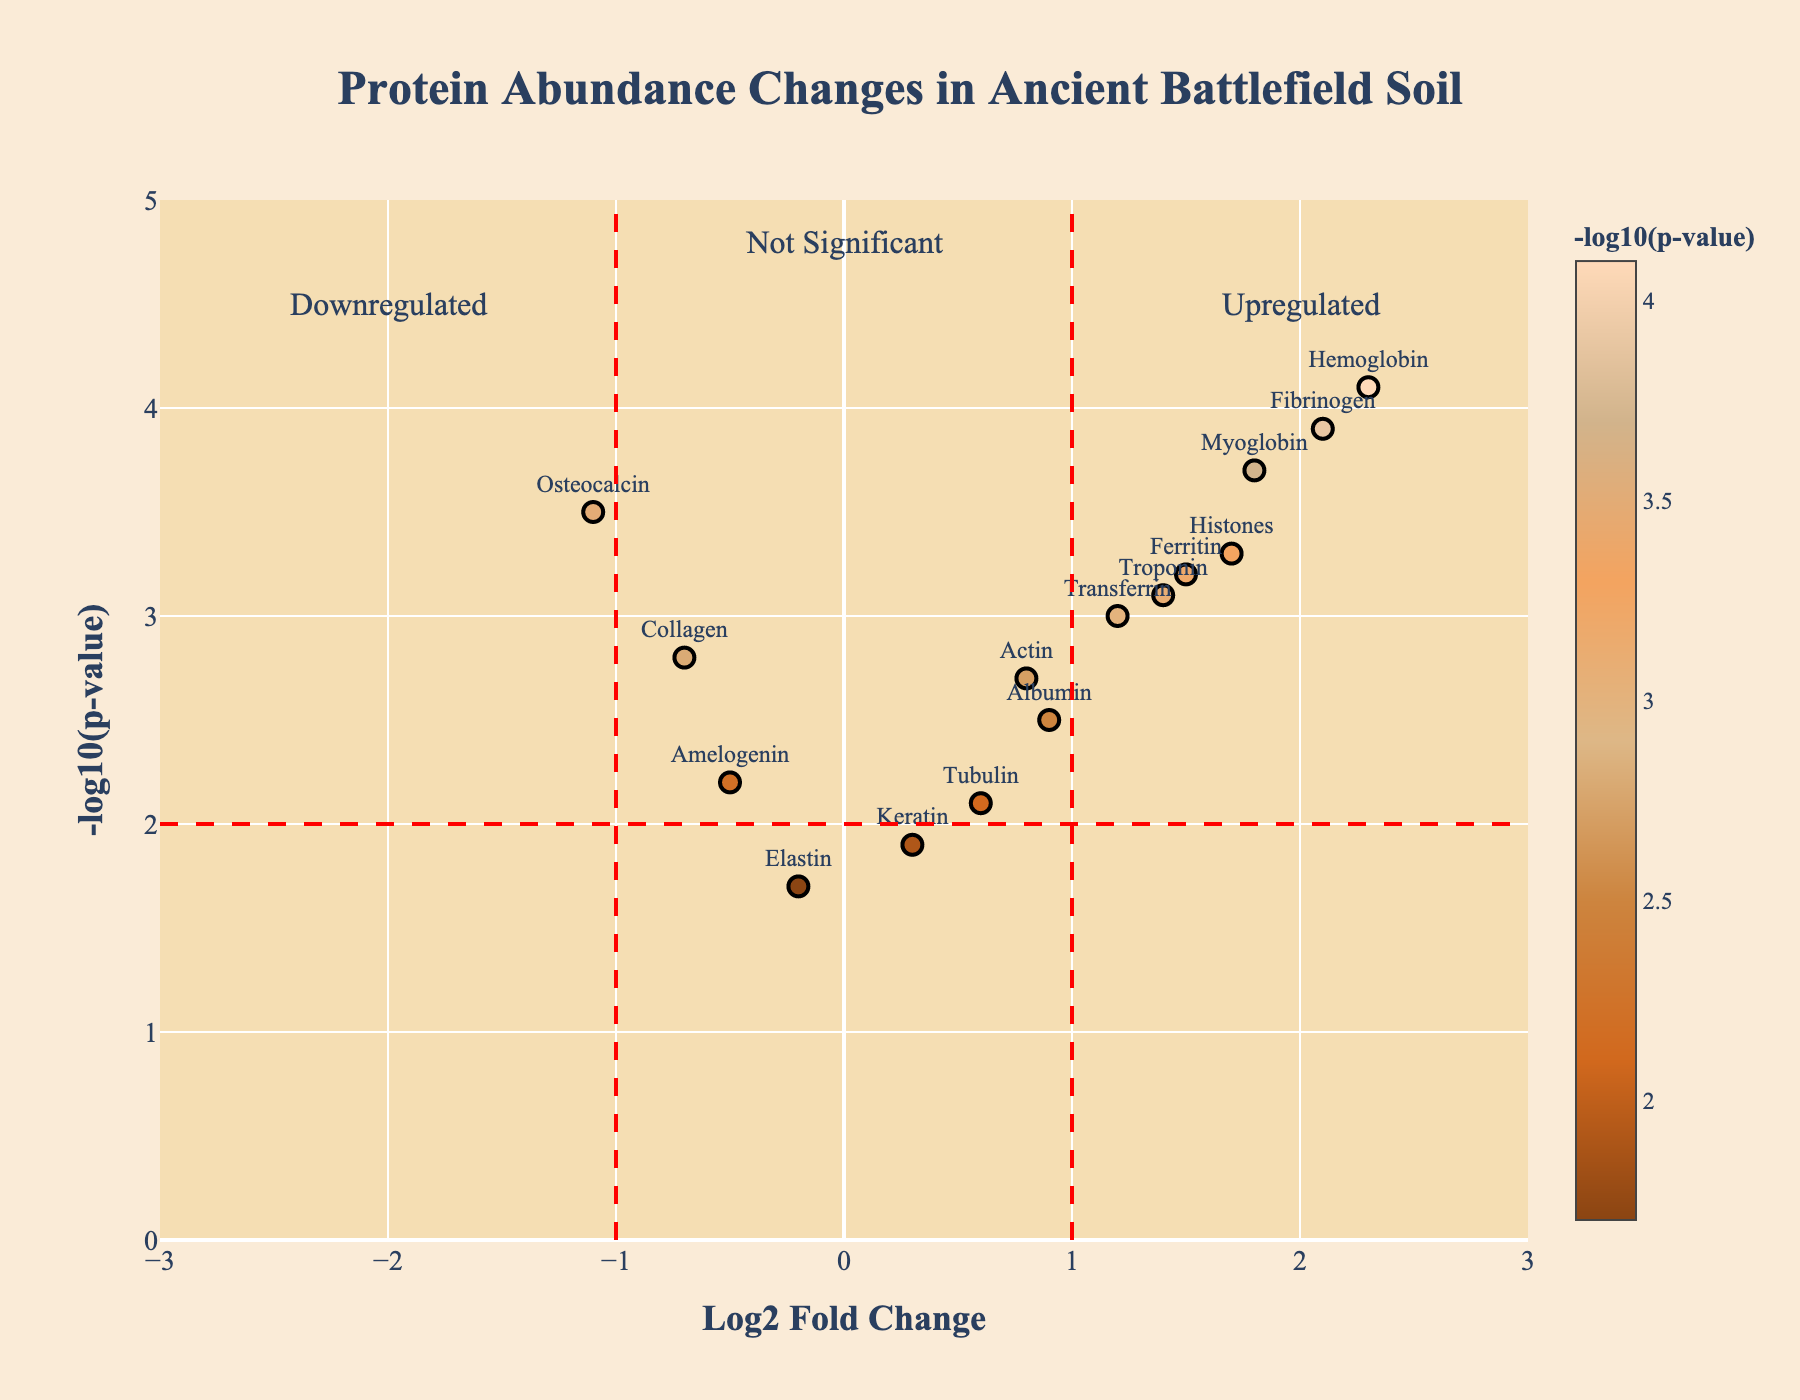What is the title of the plot? The title is displayed at the top of the plot and is phrased as "Protein Abundance Changes in Ancient Battlefield Soil"
Answer: Protein Abundance Changes in Ancient Battlefield Soil What does the x-axis represent? The x-axis usually represents the independent variable, and in this plot, it is labeled as "Log2 Fold Change" indicating the change in protein abundance on a logarithmic scale.
Answer: Log2 Fold Change What is the y-axis label? The y-axis label is given on the left side of the plot and is "NegLog10PValue," representing the negative log10 of the p-value, which is a measure of significance.
Answer: NegLog10PValue How many proteins have a Log2 Fold Change greater than 1? To count the number of proteins with a Log2 Fold Change greater than 1, look at the points to the right of the vertical line at x=1. The proteins Hemoglobin, Myoglobin, Fibrinogen, and Histones are included.
Answer: 4 Which protein has the highest Log2 Fold Change? By looking at the x-axis, the protein with the highest positive Log2 Fold Change is located farthest to the right. Hemoglobin has the highest Log2 Fold Change.
Answer: Hemoglobin How many proteins are downregulated significantly? Downregulated proteins have negative Log2 Fold Change values and significant p-values; look at points left of x=-1 and above y=2. Only Osteocalcin fits this criteria.
Answer: 1 Which protein has a NegLog10PValue closest to 3.0? Identify the point closest to the y-value of 3.0. That’s Transferrin.
Answer: Transferrin How many proteins have a Log2 Fold Change between -1 and 1 and are not significant? Points between -1 and 1 on the x-axis and below 2 on the y-axis are not significant. Proteins are Amelogenin, Keratin, Elastin, and Tubulin (4 in total).
Answer: 4 Which protein has the lowest Log2 Fold Change? Negative Log2 Fold Change indicates downregulation; the lowest value is farthest to the left. Osteocalcin has the lowest Log2 Fold Change at -1.1.
Answer: Osteocalcin Which protein is the most upregulated and also has a high p-value (significant)? Look for the most rightward point with a high y-value. Hemoglobin is the most upregulated and also has a high p-value (-log10(p-value) of 4.1).
Answer: Hemoglobin 